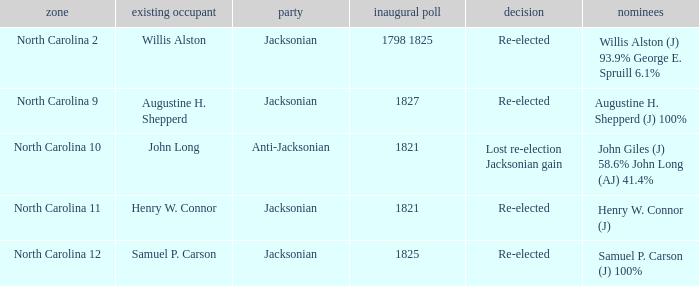Name the result for  augustine h. shepperd (j) 100% Re-elected. 